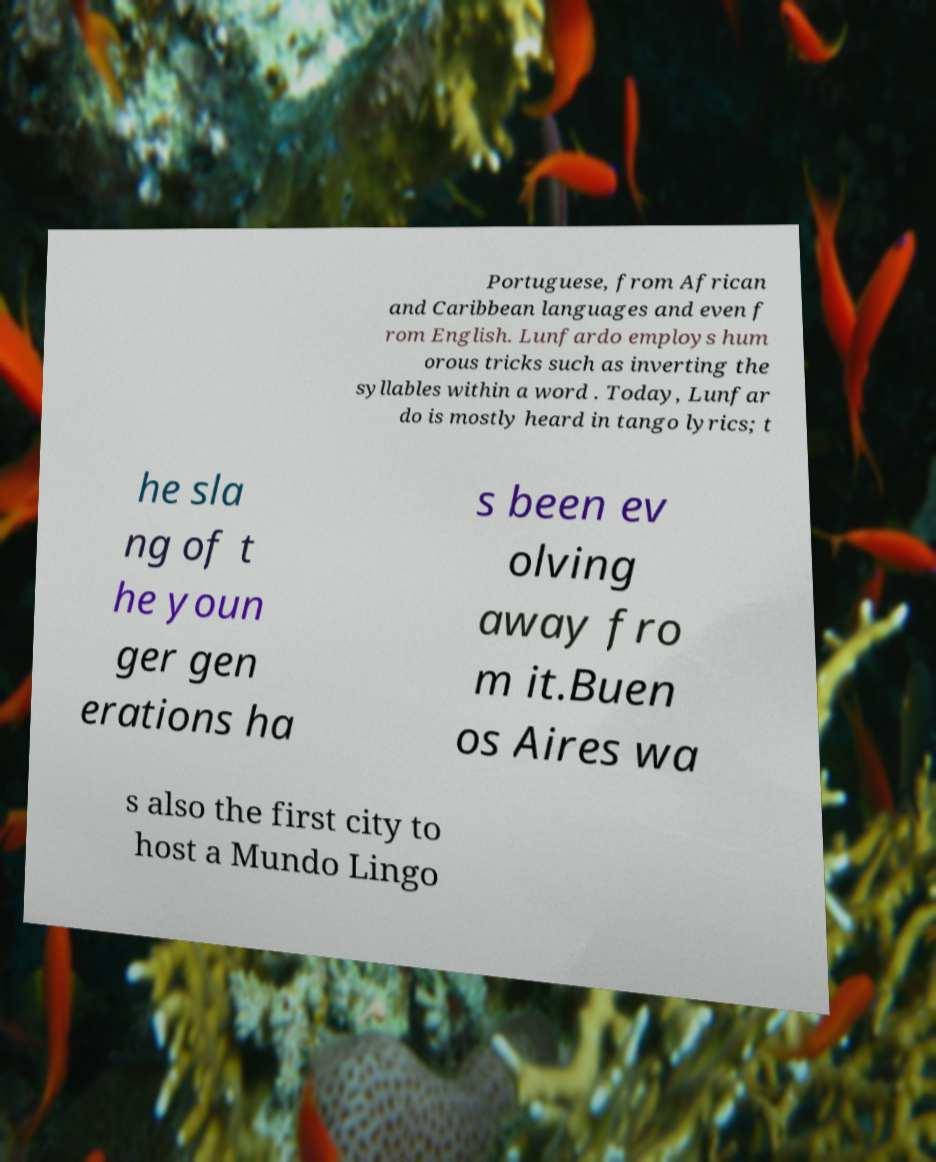What messages or text are displayed in this image? I need them in a readable, typed format. Portuguese, from African and Caribbean languages and even f rom English. Lunfardo employs hum orous tricks such as inverting the syllables within a word . Today, Lunfar do is mostly heard in tango lyrics; t he sla ng of t he youn ger gen erations ha s been ev olving away fro m it.Buen os Aires wa s also the first city to host a Mundo Lingo 